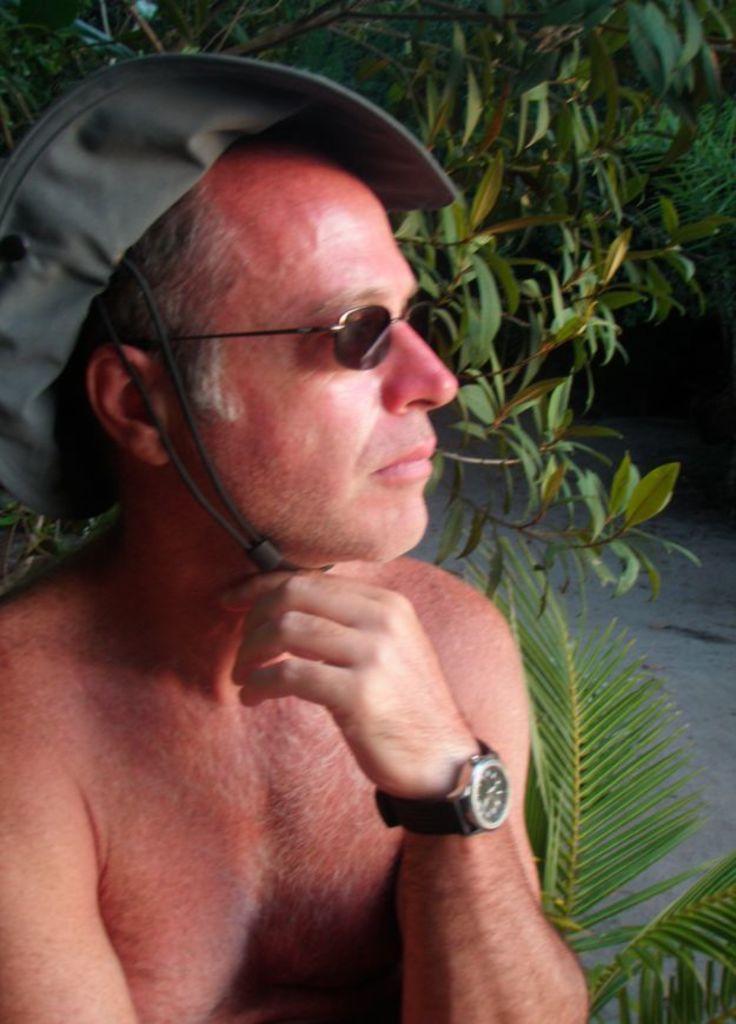Please provide a concise description of this image. In this image I can see the person wearing the watch, goggles and also hat. In the back I can see the trees which are in green color. 